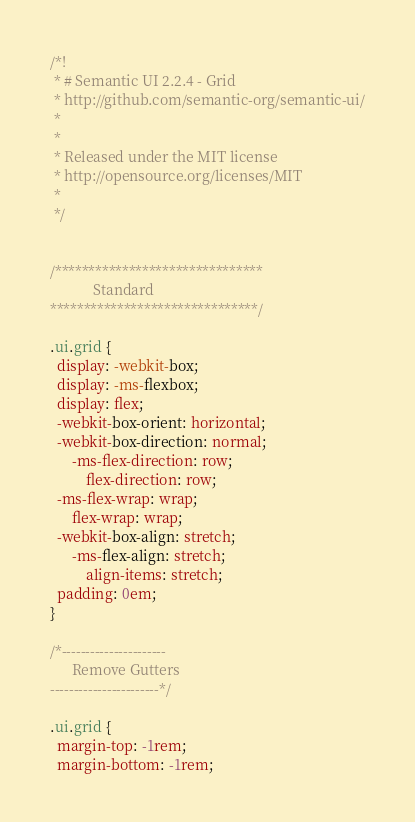<code> <loc_0><loc_0><loc_500><loc_500><_CSS_>/*!
 * # Semantic UI 2.2.4 - Grid
 * http://github.com/semantic-org/semantic-ui/
 *
 *
 * Released under the MIT license
 * http://opensource.org/licenses/MIT
 *
 */


/*******************************
            Standard
*******************************/

.ui.grid {
  display: -webkit-box;
  display: -ms-flexbox;
  display: flex;
  -webkit-box-orient: horizontal;
  -webkit-box-direction: normal;
      -ms-flex-direction: row;
          flex-direction: row;
  -ms-flex-wrap: wrap;
      flex-wrap: wrap;
  -webkit-box-align: stretch;
      -ms-flex-align: stretch;
          align-items: stretch;
  padding: 0em;
}

/*----------------------
      Remove Gutters
-----------------------*/

.ui.grid {
  margin-top: -1rem;
  margin-bottom: -1rem;</code> 